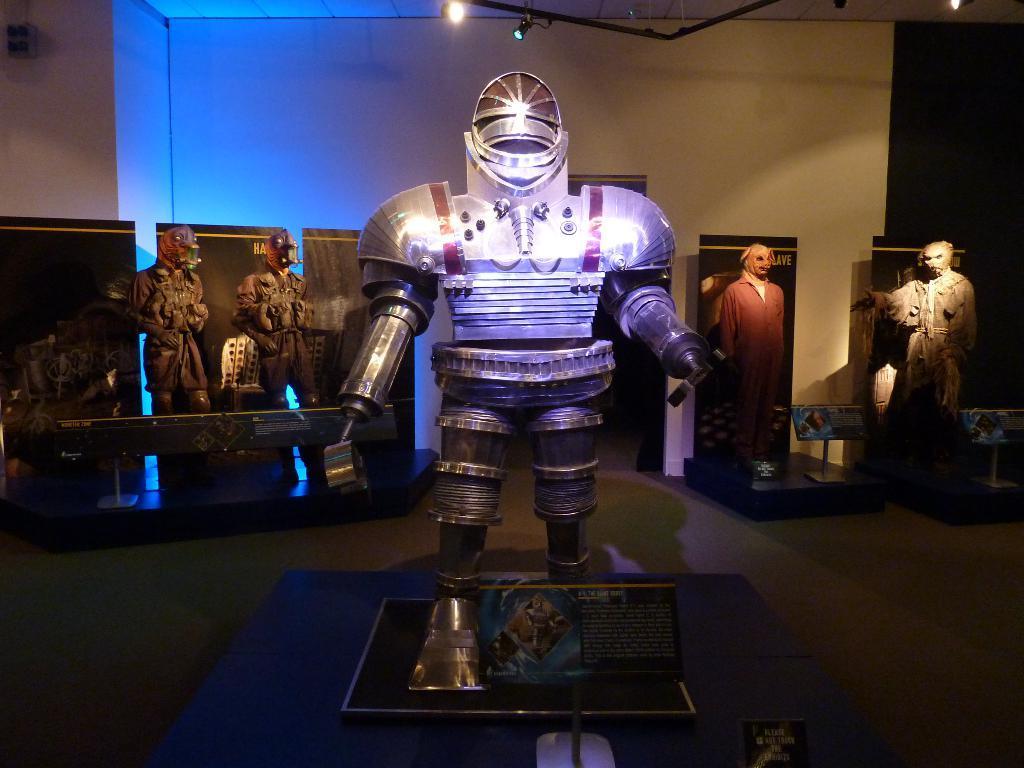Please provide a concise description of this image. In this image I can see the floor, few statues and I can see few boards in front of the statues. In the background I can see the wall, few lights and black colored banners behind the statues. 